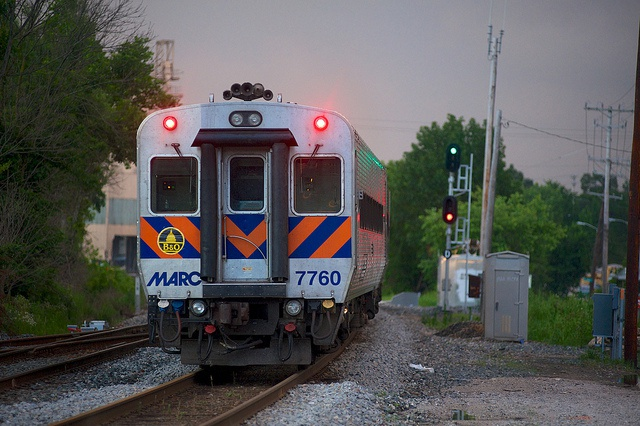Describe the objects in this image and their specific colors. I can see train in black, darkgray, gray, and navy tones, traffic light in black, gray, darkgreen, and white tones, and traffic light in black, darkgreen, khaki, and maroon tones in this image. 